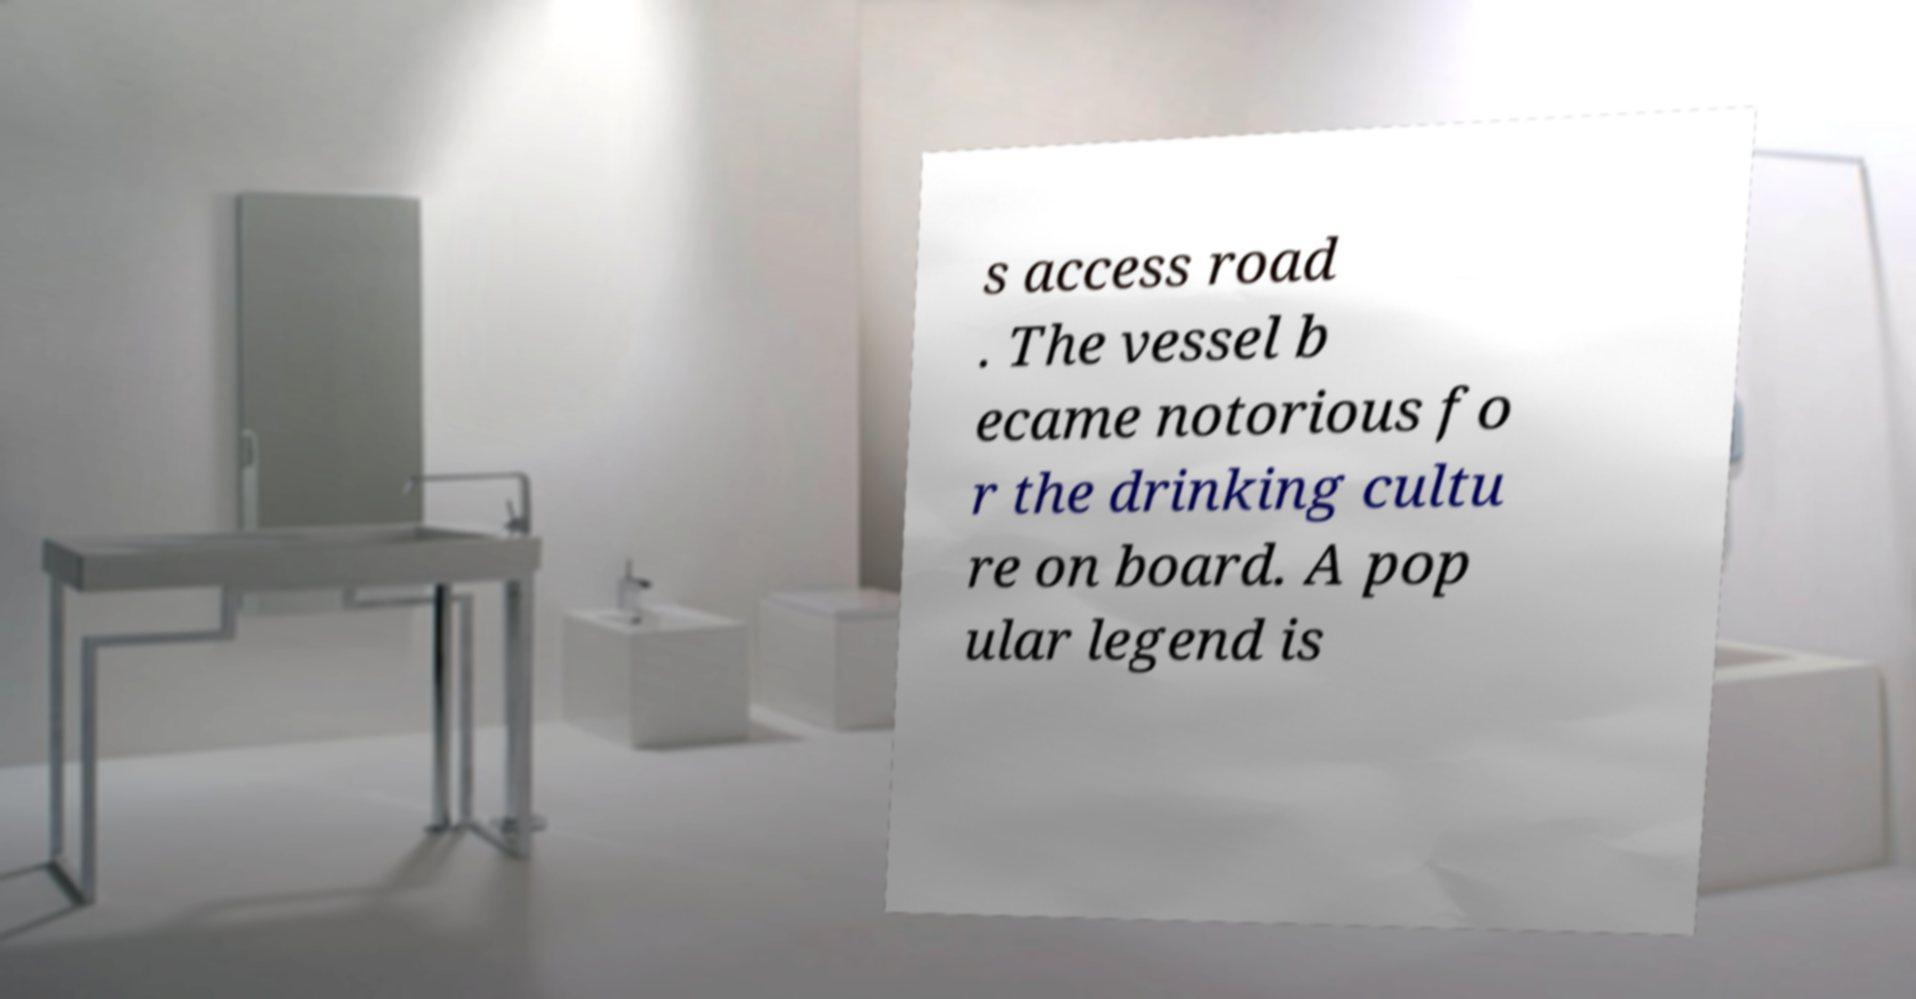There's text embedded in this image that I need extracted. Can you transcribe it verbatim? s access road . The vessel b ecame notorious fo r the drinking cultu re on board. A pop ular legend is 